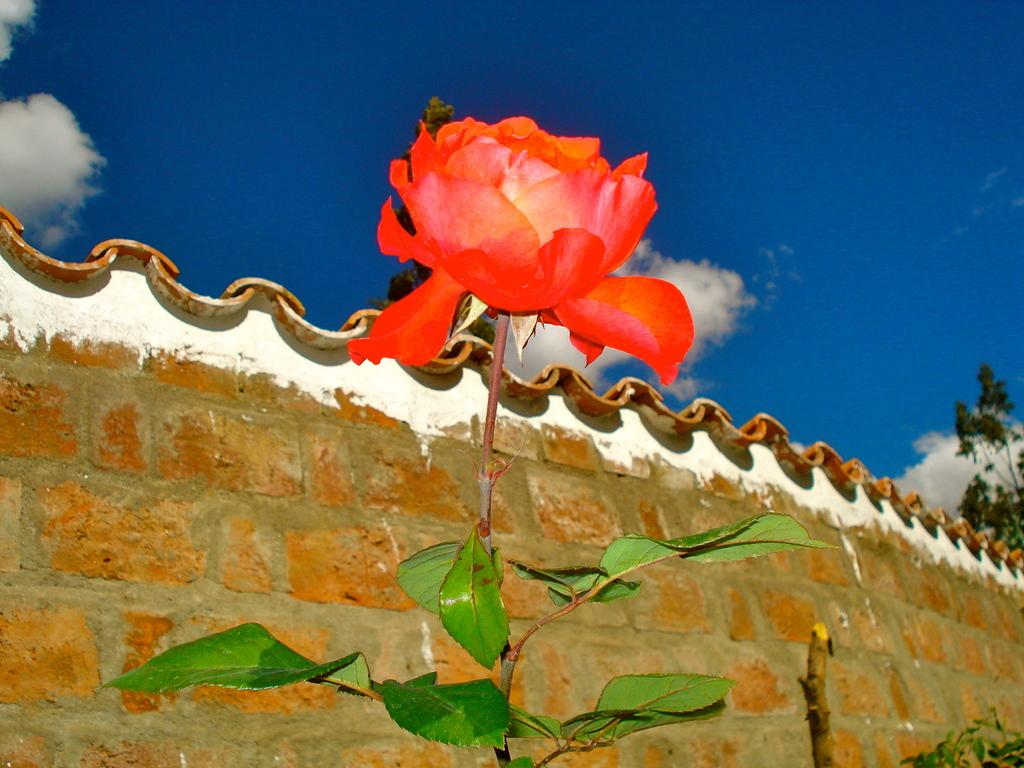What type of flower is in the image? There is a rose flower in the image. Can you describe the rose flower in more detail? The rose flower has a stem and leaves. What can be seen in the background of the image? There is a brick wall and the sky visible in the background of the image. What is the condition of the sky in the image? The sky has clouds in it. What is located on the right side of the image? There is a tree on the right side of the image. What type of cap is the rose flower wearing in the image? There is no cap present on the rose flower in the image. What process is the rose flower undergoing in the image? The rose flower is not undergoing any process in the image; it is simply a static image of a rose flower. 